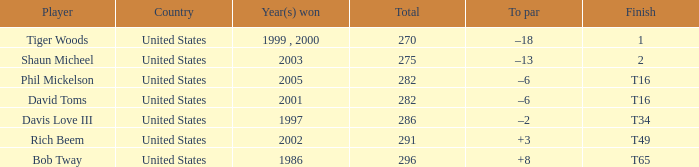In which year(s) did the person with a total greater than 286 win? 2002, 1986. 